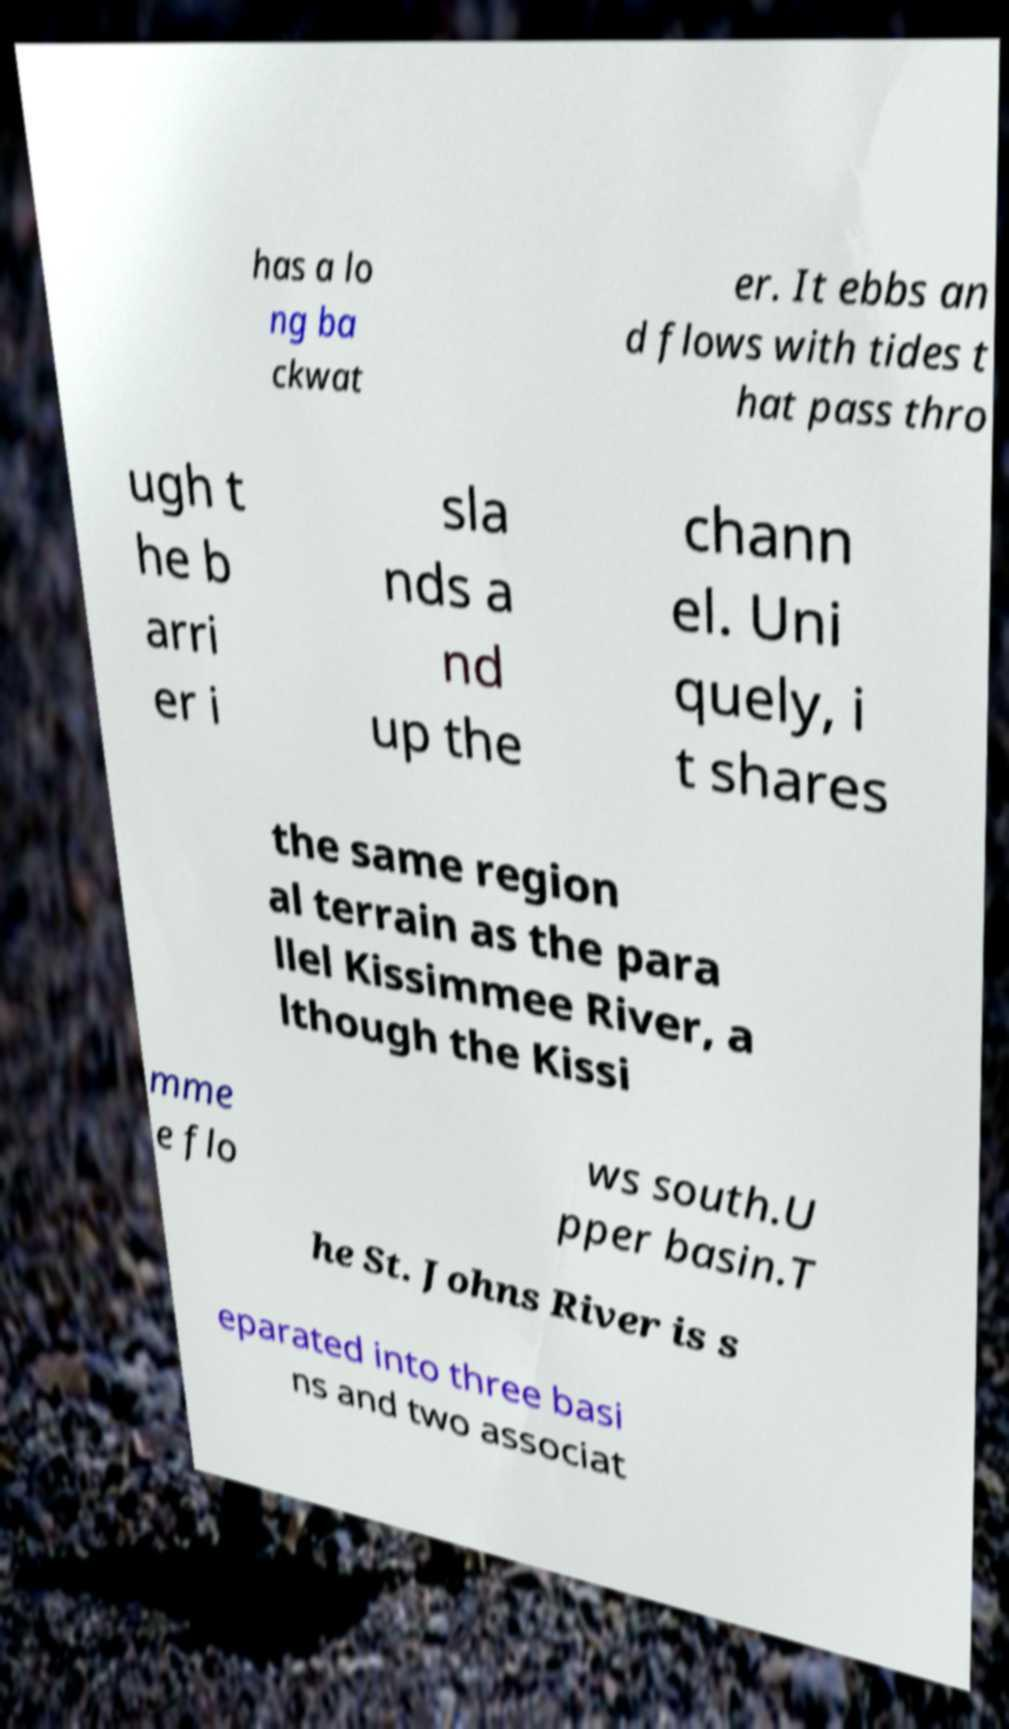Please read and relay the text visible in this image. What does it say? has a lo ng ba ckwat er. It ebbs an d flows with tides t hat pass thro ugh t he b arri er i sla nds a nd up the chann el. Uni quely, i t shares the same region al terrain as the para llel Kissimmee River, a lthough the Kissi mme e flo ws south.U pper basin.T he St. Johns River is s eparated into three basi ns and two associat 